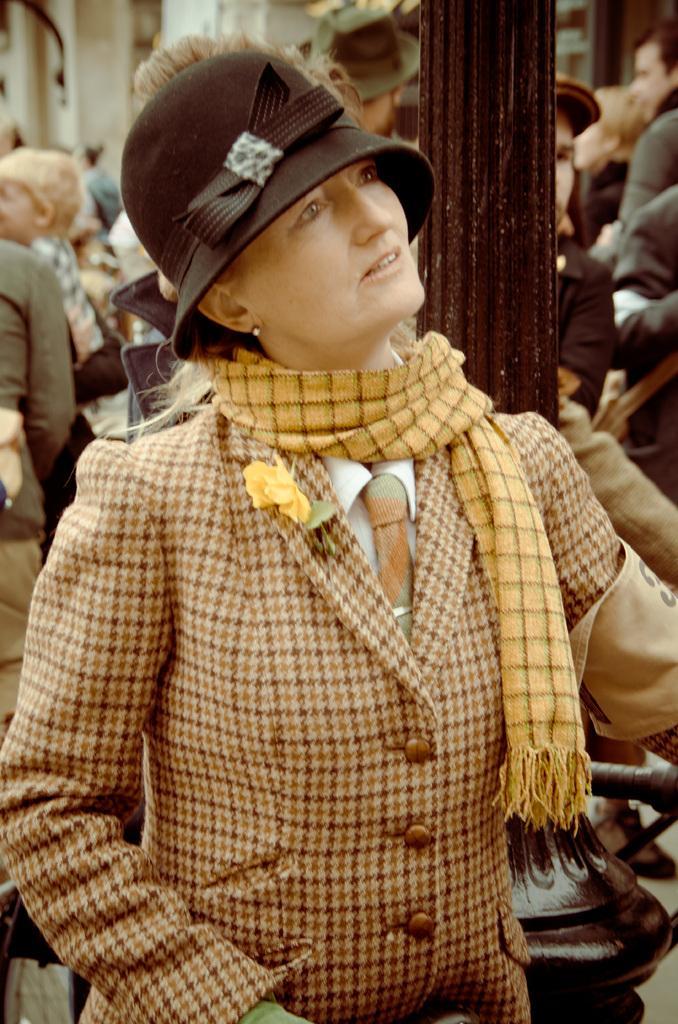In one or two sentences, can you explain what this image depicts? In this image in the foreground there is one woman who is wearing a scarf and hat, in the background there are a group of people, pole and buildings. 